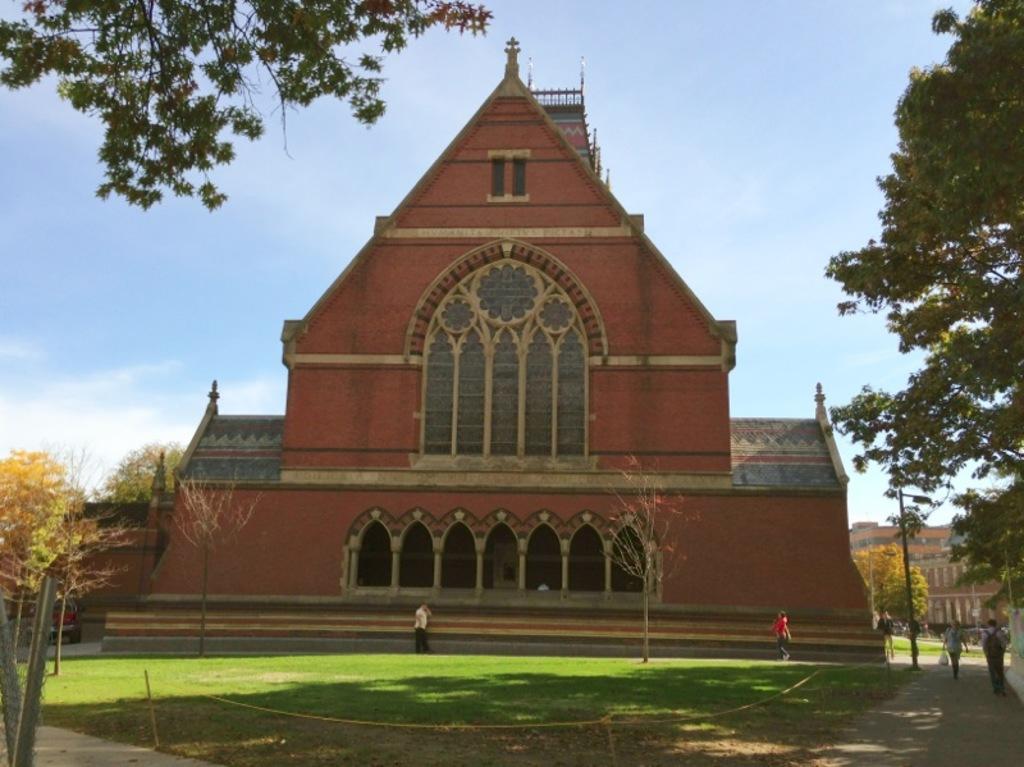How would you summarize this image in a sentence or two? In this image there are group of people , buildings, trees, and in the background there is sky. 